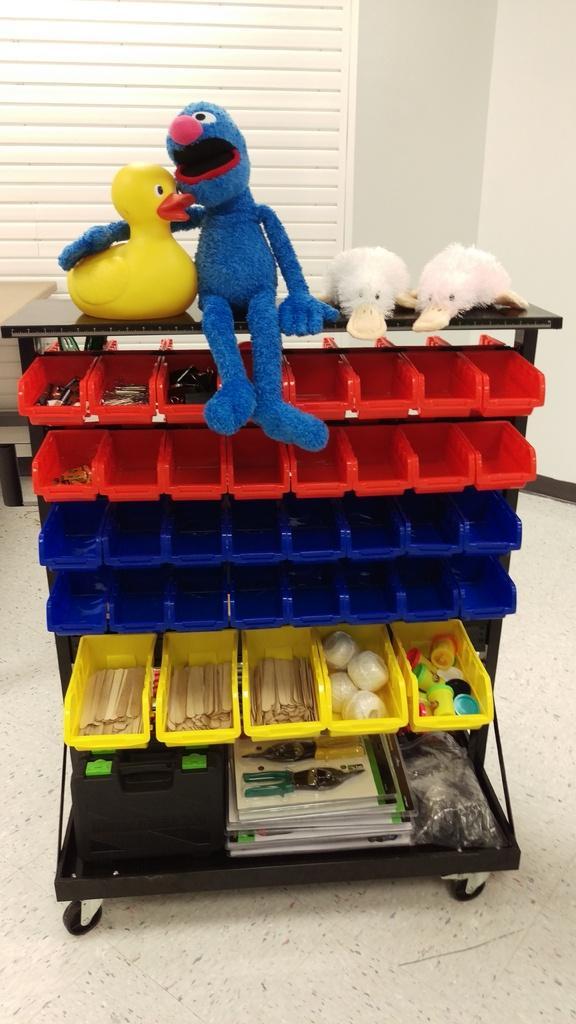Could you give a brief overview of what you see in this image? In this image there are few toys and some objects are arranged in a rack. 